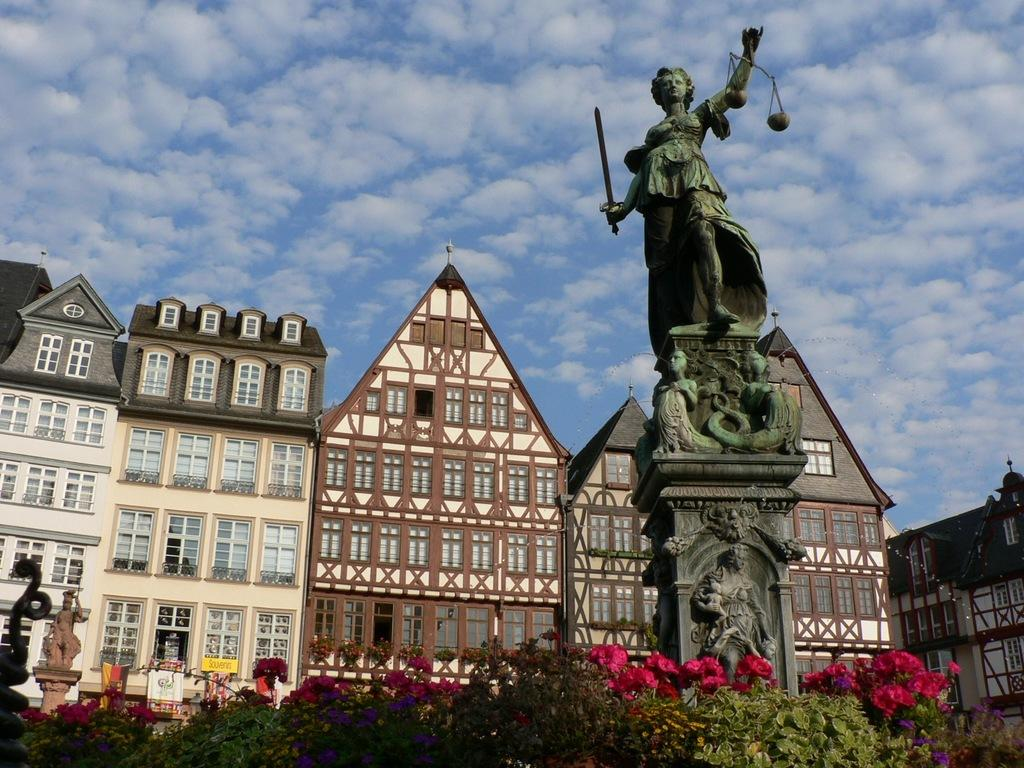What type of structures can be seen in the image? There are buildings in the image. What decorative elements are present on the buildings? There are statues on pillars in the image. What type of vegetation is present in the image? There are plants with flowers in the image. What is visible in the background of the image? The sky is visible in the image. What can be observed in the sky? Clouds are present in the sky. What type of authority is depicted in the image? There is no specific authority figure depicted in the image; it features buildings, statues, plants, and the sky. How many apples are hanging from the plants in the image? There are no apples present in the image; the plants have flowers instead. 